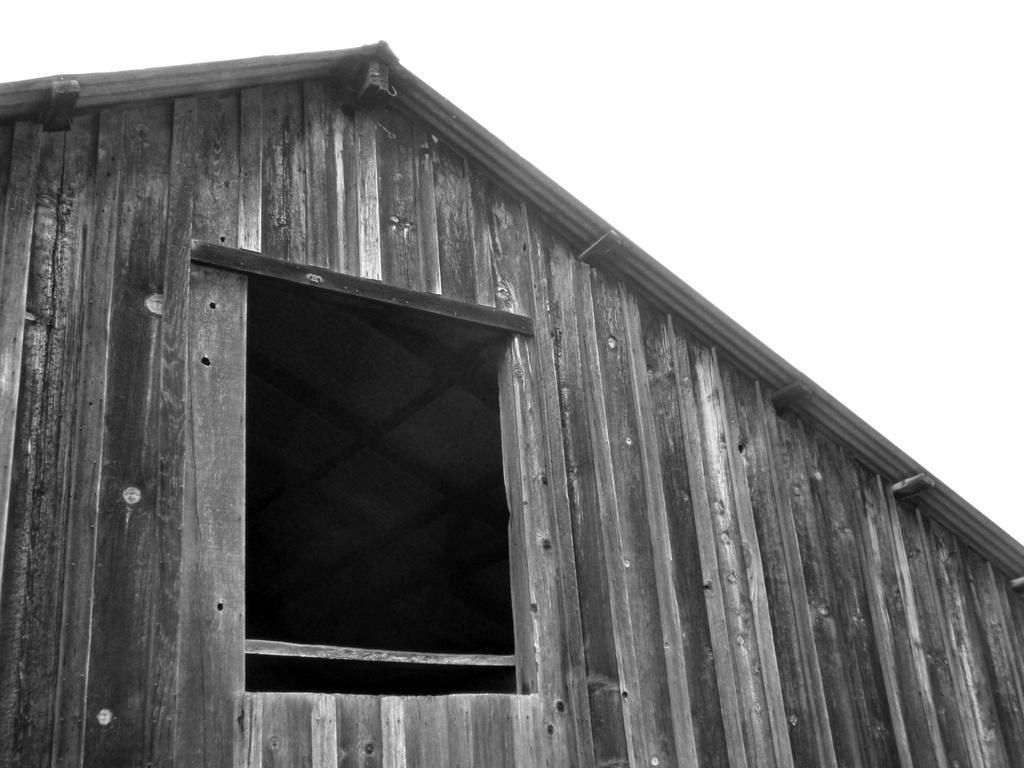Please provide a concise description of this image. This is a black and white image of a building with wooden wall. Also there is a square hole in the wall. In the background it is white. 